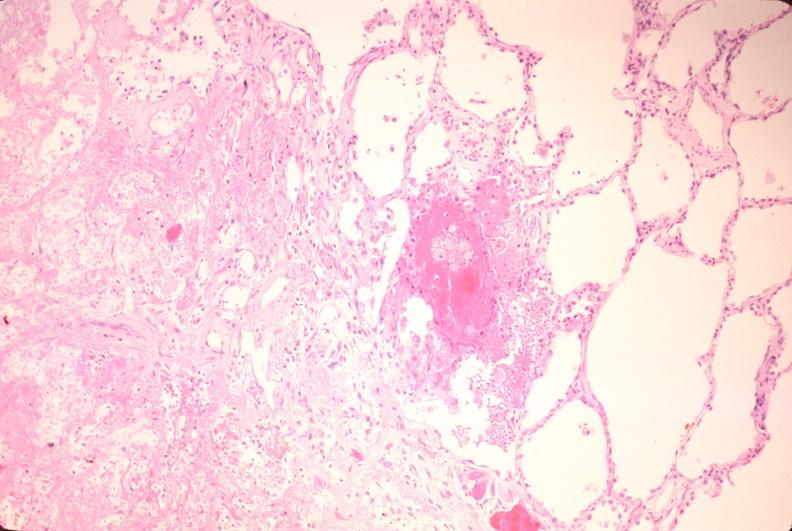does interstitial cell tumor show lung, infarct, acute and organized?
Answer the question using a single word or phrase. No 